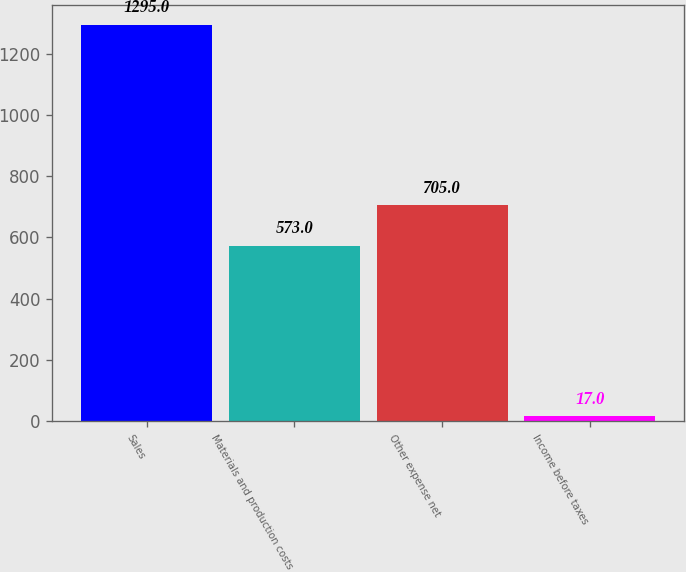<chart> <loc_0><loc_0><loc_500><loc_500><bar_chart><fcel>Sales<fcel>Materials and production costs<fcel>Other expense net<fcel>Income before taxes<nl><fcel>1295<fcel>573<fcel>705<fcel>17<nl></chart> 